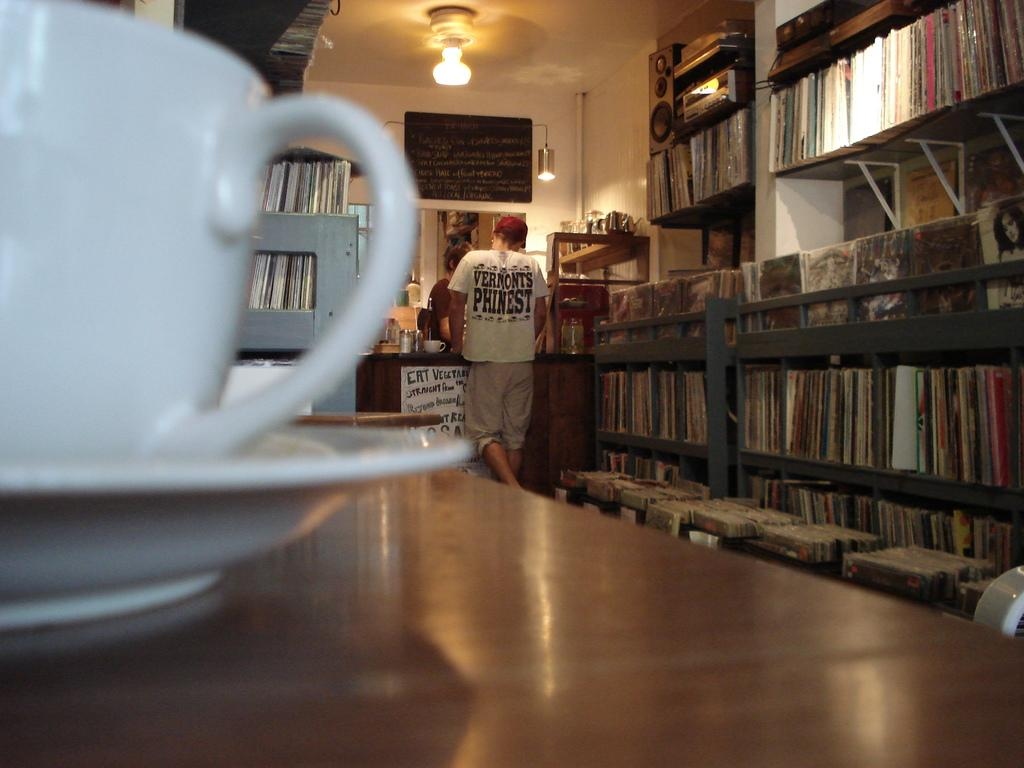<image>
Share a concise interpretation of the image provided. Man at the checkout of the front counter talking with the customer service person, cup featured on a table, and the man is wearing Vermont's finest shirt. 